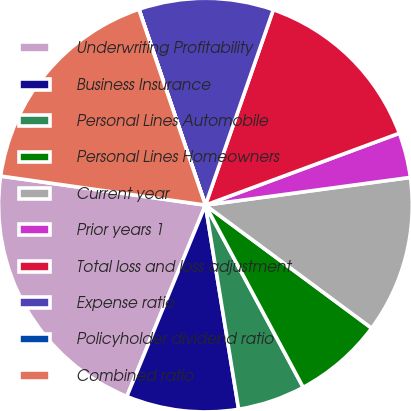Convert chart to OTSL. <chart><loc_0><loc_0><loc_500><loc_500><pie_chart><fcel>Underwriting Profitability<fcel>Business Insurance<fcel>Personal Lines Automobile<fcel>Personal Lines Homeowners<fcel>Current year<fcel>Prior years 1<fcel>Total loss and loss adjustment<fcel>Expense ratio<fcel>Policyholder dividend ratio<fcel>Combined ratio<nl><fcel>21.04%<fcel>8.77%<fcel>5.27%<fcel>7.02%<fcel>12.28%<fcel>3.51%<fcel>14.03%<fcel>10.53%<fcel>0.01%<fcel>17.54%<nl></chart> 